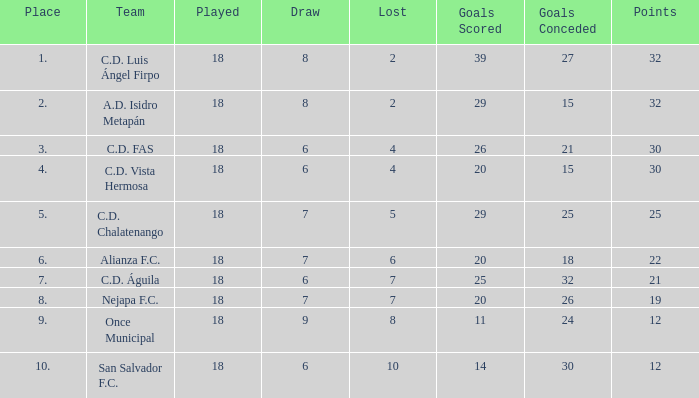What is the minimum played with a lost exceeding 10? None. 